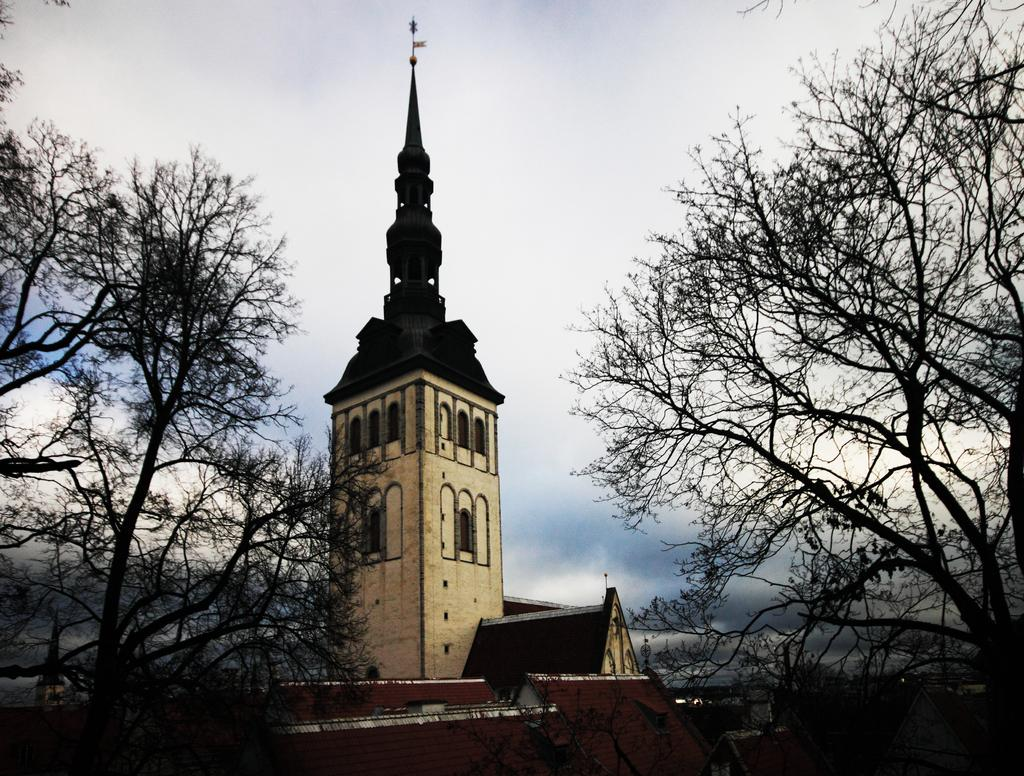What type of natural elements can be seen in the image? There are trees in the image. What type of structures are visible in the image? There are roofs, buildings, and windows in the image. What else can be found in the image besides the structures and trees? There are objects in the image. What is visible in the sky in the image? There are clouds in the sky in the image. Can you describe the bead detail on the roof of the building in the image? There is no bead detail mentioned in the provided facts, and the image does not show any bead detail on the roof of the building. What type of rod is holding the clouds in the sky in the image? There is no rod holding the clouds in the sky in the image, as clouds are naturally suspended in the atmosphere. 